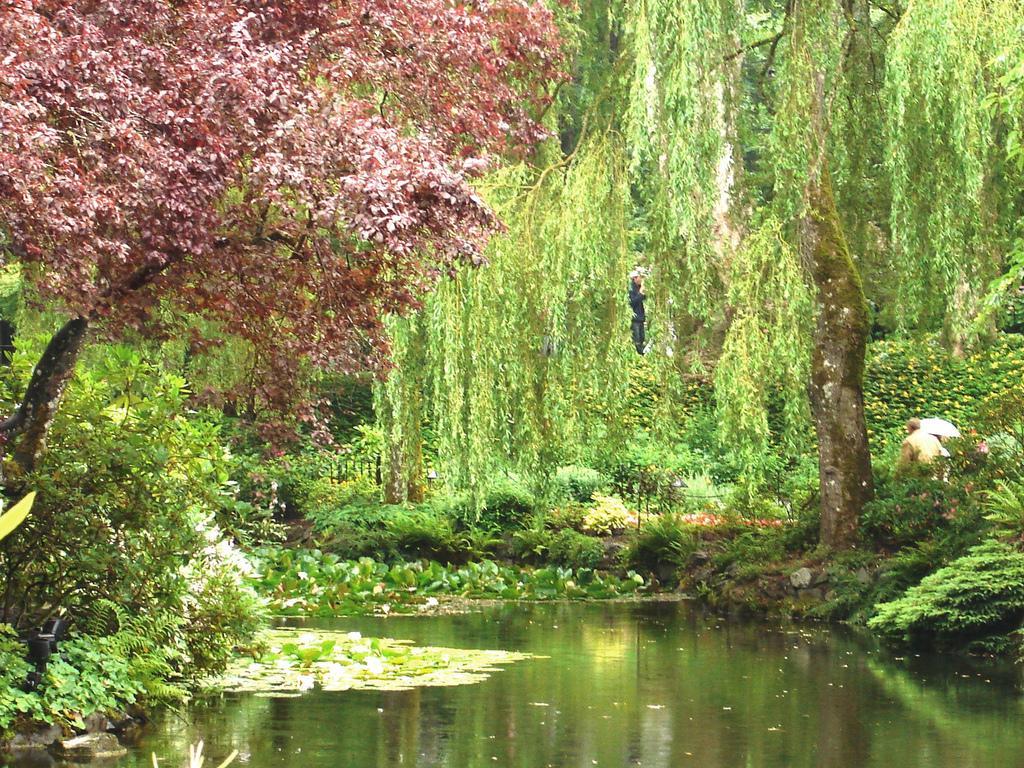Can you describe this image briefly? In the image we can see trees, grass, plants and the water. 